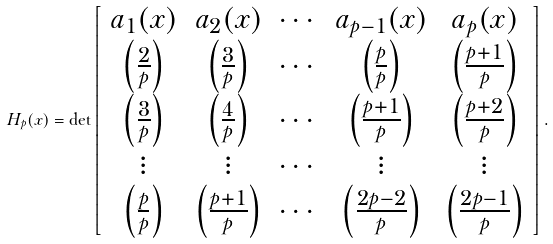Convert formula to latex. <formula><loc_0><loc_0><loc_500><loc_500>H _ { p } ( x ) = \det \left [ \begin{array} { c c c c c } a _ { 1 } ( x ) & a _ { 2 } ( x ) & \cdots & a _ { p - 1 } ( x ) & a _ { p } ( x ) \\ \left ( \frac { 2 } { p } \right ) & \left ( \frac { 3 } { p } \right ) & \cdots & \left ( \frac { p } { p } \right ) & \left ( \frac { p + 1 } { p } \right ) \\ \left ( \frac { 3 } { p } \right ) & \left ( \frac { 4 } { p } \right ) & \cdots & \left ( \frac { p + 1 } { p } \right ) & \left ( \frac { p + 2 } { p } \right ) \\ \vdots & \vdots & \cdots & \vdots & \vdots \\ \left ( \frac { p } { p } \right ) & \left ( \frac { p + 1 } { p } \right ) & \cdots & \left ( \frac { 2 p - 2 } { p } \right ) & \left ( \frac { 2 p - 1 } { p } \right ) \end{array} \right ] .</formula> 